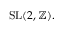<formula> <loc_0><loc_0><loc_500><loc_500>{ S L } ( 2 , \mathbb { Z } ) .</formula> 